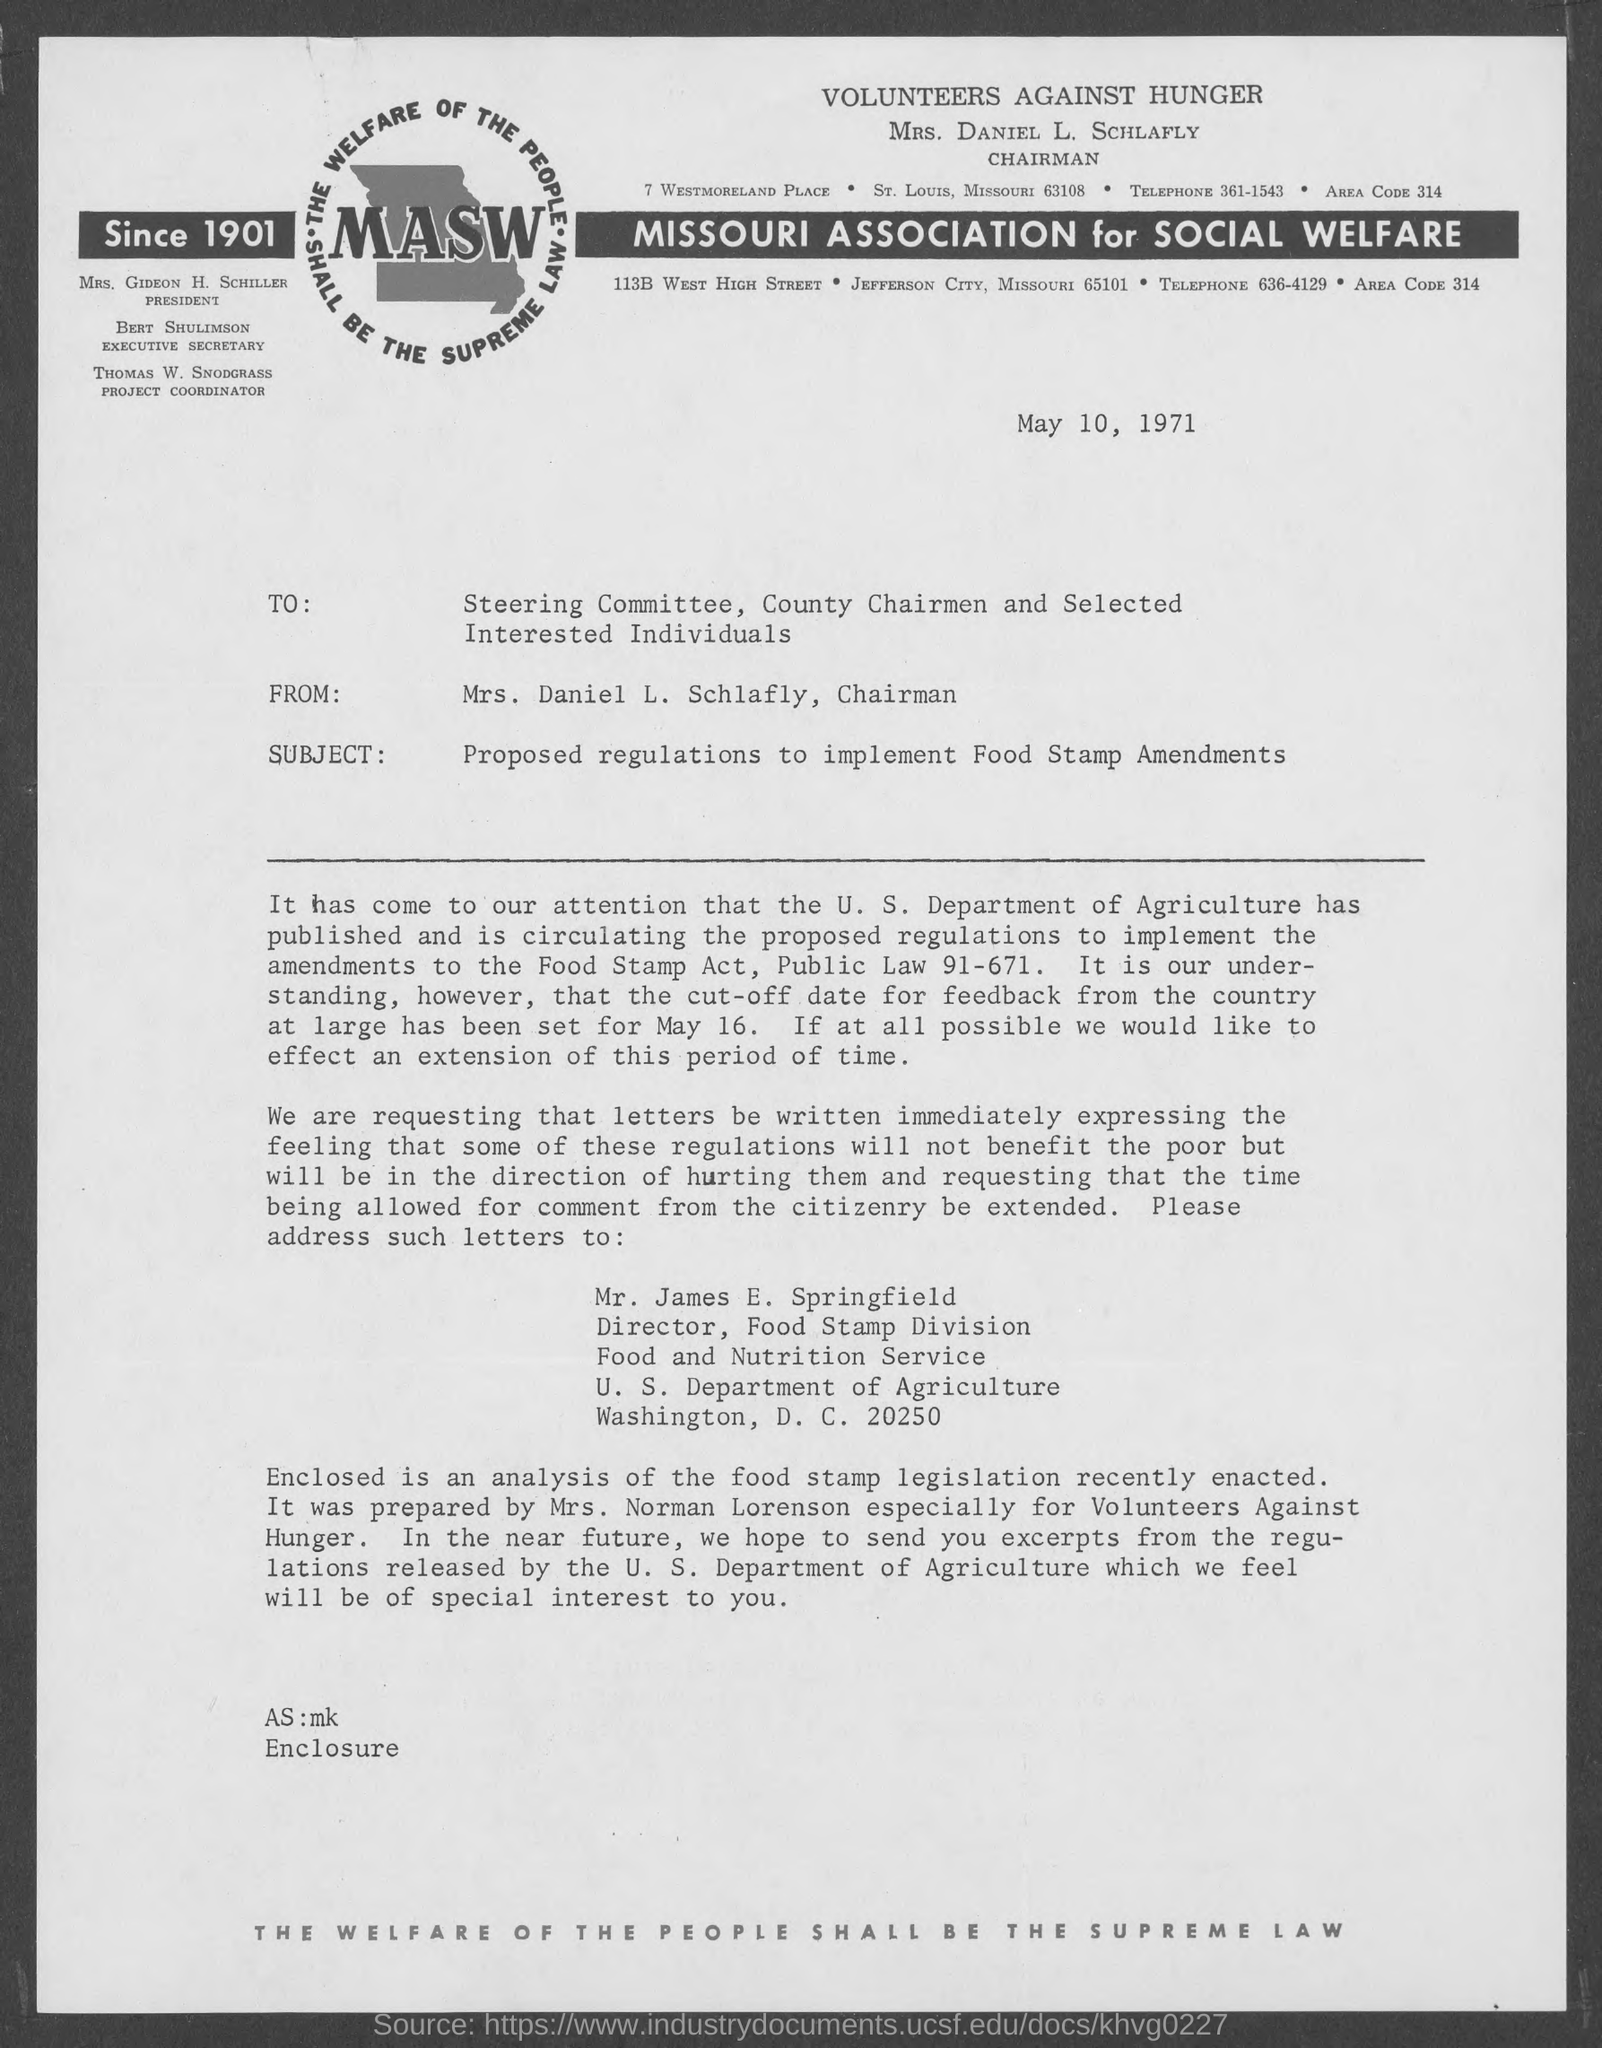Specify some key components in this picture. Thomas W. Snodgrass holds the position of Project Coordinator. Mrs. Gideon H. Schiller holds the position of president. Mrs. Daniel L. Schlafly holds the position of Chairman. Bert Shulimson holds the position of Executive Secretary. 